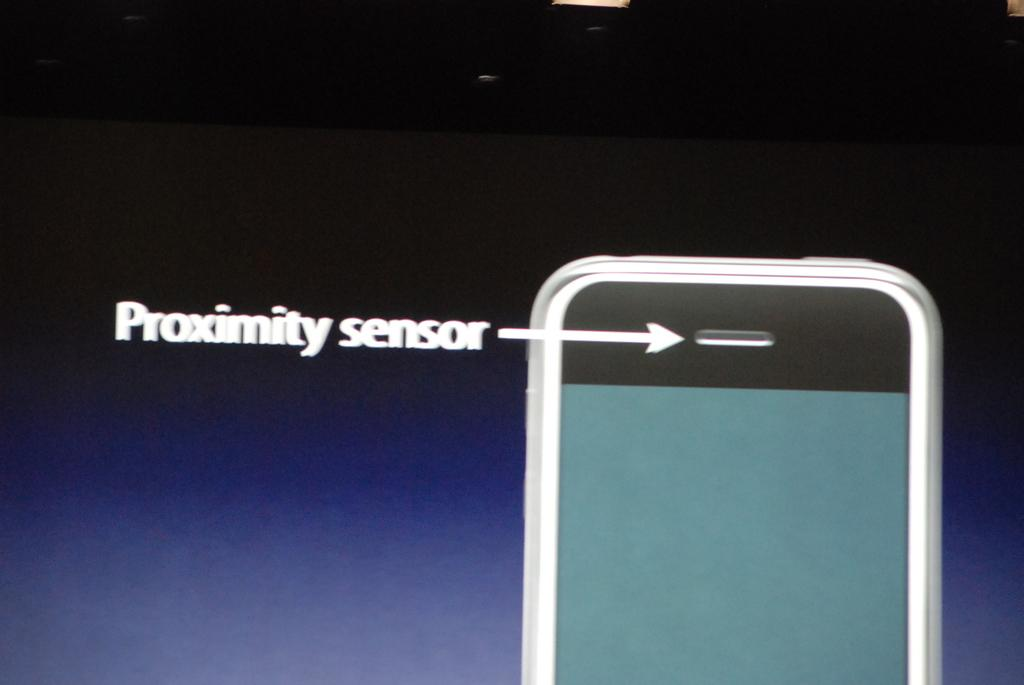<image>
Describe the image concisely. A proximity sensor arrow pointing at an image of a phone. 